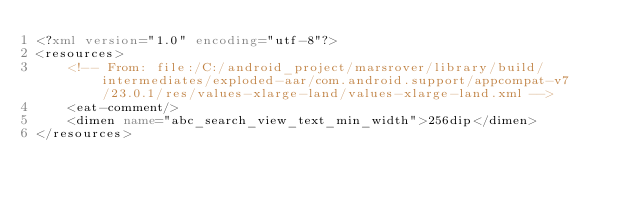Convert code to text. <code><loc_0><loc_0><loc_500><loc_500><_XML_><?xml version="1.0" encoding="utf-8"?>
<resources>
    <!-- From: file:/C:/android_project/marsrover/library/build/intermediates/exploded-aar/com.android.support/appcompat-v7/23.0.1/res/values-xlarge-land/values-xlarge-land.xml -->
    <eat-comment/>
    <dimen name="abc_search_view_text_min_width">256dip</dimen>
</resources></code> 